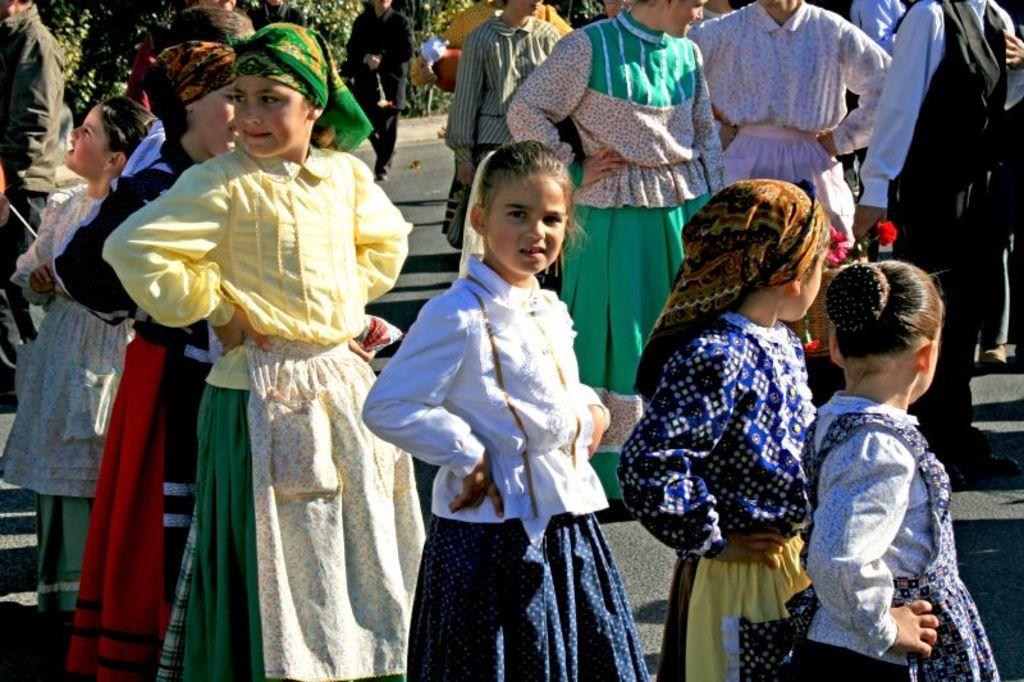How many people are present in the image? There are many people in the image. What are some people wearing on their heads? Some people are wearing scarves on their heads. What can be seen in the background of the image? There are trees in the background of the image. How many toes does the girl have in the image? There is no girl present in the image, so it is not possible to determine the number of toes. 